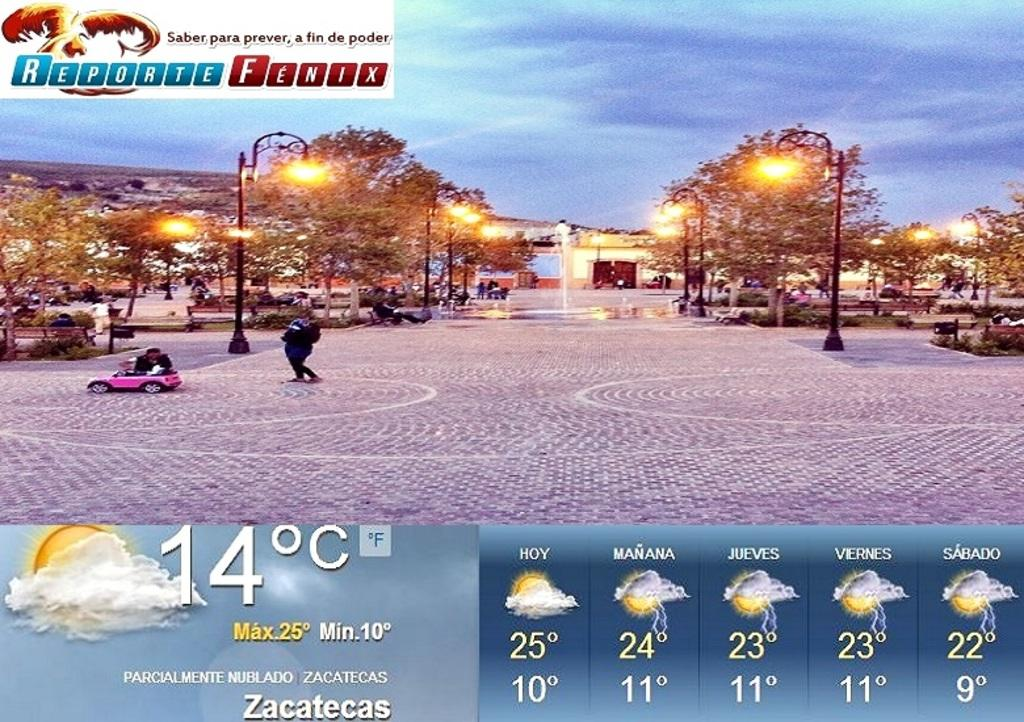<image>
Relay a brief, clear account of the picture shown. a weather report page named Reporte Fenix shows 14 for Zacatecas 